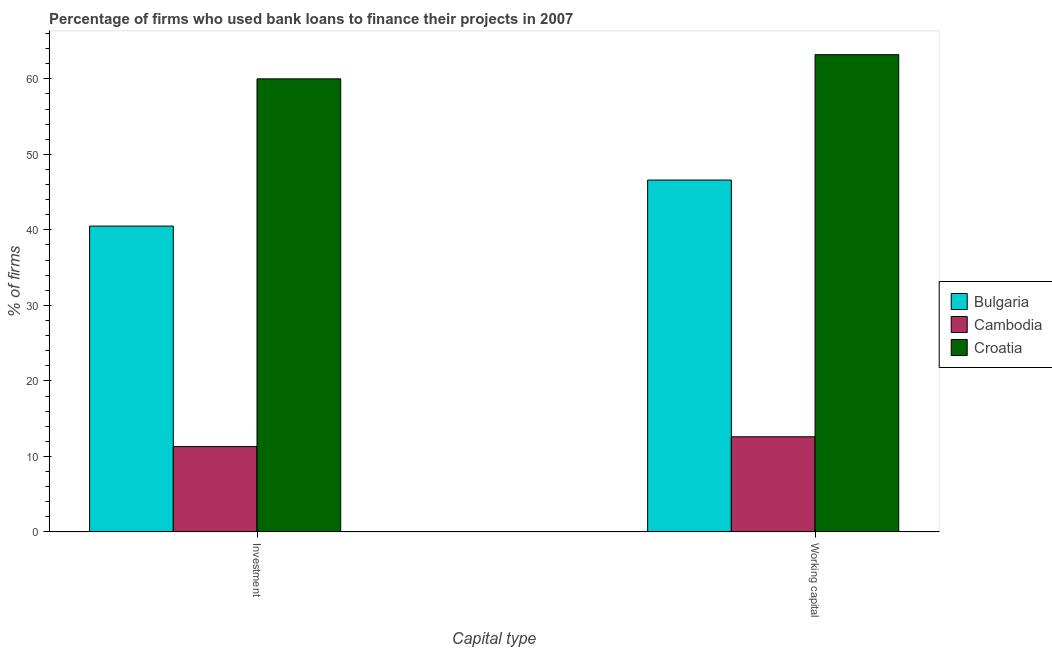Are the number of bars per tick equal to the number of legend labels?
Your response must be concise. Yes. Are the number of bars on each tick of the X-axis equal?
Make the answer very short. Yes. What is the label of the 2nd group of bars from the left?
Your answer should be compact. Working capital. What is the percentage of firms using banks to finance working capital in Bulgaria?
Your answer should be compact. 46.6. Across all countries, what is the minimum percentage of firms using banks to finance investment?
Provide a succinct answer. 11.3. In which country was the percentage of firms using banks to finance working capital maximum?
Offer a terse response. Croatia. In which country was the percentage of firms using banks to finance investment minimum?
Your answer should be compact. Cambodia. What is the total percentage of firms using banks to finance working capital in the graph?
Your response must be concise. 122.4. What is the difference between the percentage of firms using banks to finance working capital in Cambodia and that in Croatia?
Your answer should be very brief. -50.6. What is the difference between the percentage of firms using banks to finance working capital in Cambodia and the percentage of firms using banks to finance investment in Bulgaria?
Offer a terse response. -27.9. What is the average percentage of firms using banks to finance working capital per country?
Give a very brief answer. 40.8. What is the difference between the percentage of firms using banks to finance working capital and percentage of firms using banks to finance investment in Cambodia?
Give a very brief answer. 1.3. What is the ratio of the percentage of firms using banks to finance investment in Bulgaria to that in Croatia?
Ensure brevity in your answer.  0.68. Is the percentage of firms using banks to finance investment in Croatia less than that in Cambodia?
Offer a very short reply. No. What does the 2nd bar from the right in Investment represents?
Ensure brevity in your answer.  Cambodia. Are all the bars in the graph horizontal?
Your answer should be very brief. No. How many countries are there in the graph?
Give a very brief answer. 3. What is the difference between two consecutive major ticks on the Y-axis?
Your response must be concise. 10. Are the values on the major ticks of Y-axis written in scientific E-notation?
Ensure brevity in your answer.  No. Does the graph contain grids?
Ensure brevity in your answer.  No. Where does the legend appear in the graph?
Your answer should be compact. Center right. How are the legend labels stacked?
Ensure brevity in your answer.  Vertical. What is the title of the graph?
Your answer should be very brief. Percentage of firms who used bank loans to finance their projects in 2007. Does "Myanmar" appear as one of the legend labels in the graph?
Offer a very short reply. No. What is the label or title of the X-axis?
Provide a short and direct response. Capital type. What is the label or title of the Y-axis?
Offer a very short reply. % of firms. What is the % of firms of Bulgaria in Investment?
Your response must be concise. 40.5. What is the % of firms in Cambodia in Investment?
Your answer should be very brief. 11.3. What is the % of firms of Bulgaria in Working capital?
Your answer should be compact. 46.6. What is the % of firms in Cambodia in Working capital?
Your answer should be compact. 12.6. What is the % of firms of Croatia in Working capital?
Your answer should be compact. 63.2. Across all Capital type, what is the maximum % of firms in Bulgaria?
Provide a succinct answer. 46.6. Across all Capital type, what is the maximum % of firms in Cambodia?
Ensure brevity in your answer.  12.6. Across all Capital type, what is the maximum % of firms of Croatia?
Your answer should be very brief. 63.2. Across all Capital type, what is the minimum % of firms of Bulgaria?
Make the answer very short. 40.5. Across all Capital type, what is the minimum % of firms in Cambodia?
Give a very brief answer. 11.3. Across all Capital type, what is the minimum % of firms of Croatia?
Your answer should be very brief. 60. What is the total % of firms of Bulgaria in the graph?
Offer a terse response. 87.1. What is the total % of firms of Cambodia in the graph?
Offer a terse response. 23.9. What is the total % of firms of Croatia in the graph?
Make the answer very short. 123.2. What is the difference between the % of firms of Bulgaria in Investment and that in Working capital?
Ensure brevity in your answer.  -6.1. What is the difference between the % of firms of Croatia in Investment and that in Working capital?
Keep it short and to the point. -3.2. What is the difference between the % of firms of Bulgaria in Investment and the % of firms of Cambodia in Working capital?
Provide a succinct answer. 27.9. What is the difference between the % of firms of Bulgaria in Investment and the % of firms of Croatia in Working capital?
Provide a short and direct response. -22.7. What is the difference between the % of firms of Cambodia in Investment and the % of firms of Croatia in Working capital?
Provide a short and direct response. -51.9. What is the average % of firms in Bulgaria per Capital type?
Keep it short and to the point. 43.55. What is the average % of firms of Cambodia per Capital type?
Provide a short and direct response. 11.95. What is the average % of firms in Croatia per Capital type?
Ensure brevity in your answer.  61.6. What is the difference between the % of firms in Bulgaria and % of firms in Cambodia in Investment?
Your answer should be compact. 29.2. What is the difference between the % of firms of Bulgaria and % of firms of Croatia in Investment?
Keep it short and to the point. -19.5. What is the difference between the % of firms in Cambodia and % of firms in Croatia in Investment?
Ensure brevity in your answer.  -48.7. What is the difference between the % of firms of Bulgaria and % of firms of Cambodia in Working capital?
Offer a very short reply. 34. What is the difference between the % of firms of Bulgaria and % of firms of Croatia in Working capital?
Provide a succinct answer. -16.6. What is the difference between the % of firms in Cambodia and % of firms in Croatia in Working capital?
Keep it short and to the point. -50.6. What is the ratio of the % of firms of Bulgaria in Investment to that in Working capital?
Ensure brevity in your answer.  0.87. What is the ratio of the % of firms in Cambodia in Investment to that in Working capital?
Keep it short and to the point. 0.9. What is the ratio of the % of firms in Croatia in Investment to that in Working capital?
Your answer should be compact. 0.95. What is the difference between the highest and the second highest % of firms of Bulgaria?
Give a very brief answer. 6.1. What is the difference between the highest and the second highest % of firms of Croatia?
Keep it short and to the point. 3.2. What is the difference between the highest and the lowest % of firms in Croatia?
Your answer should be very brief. 3.2. 